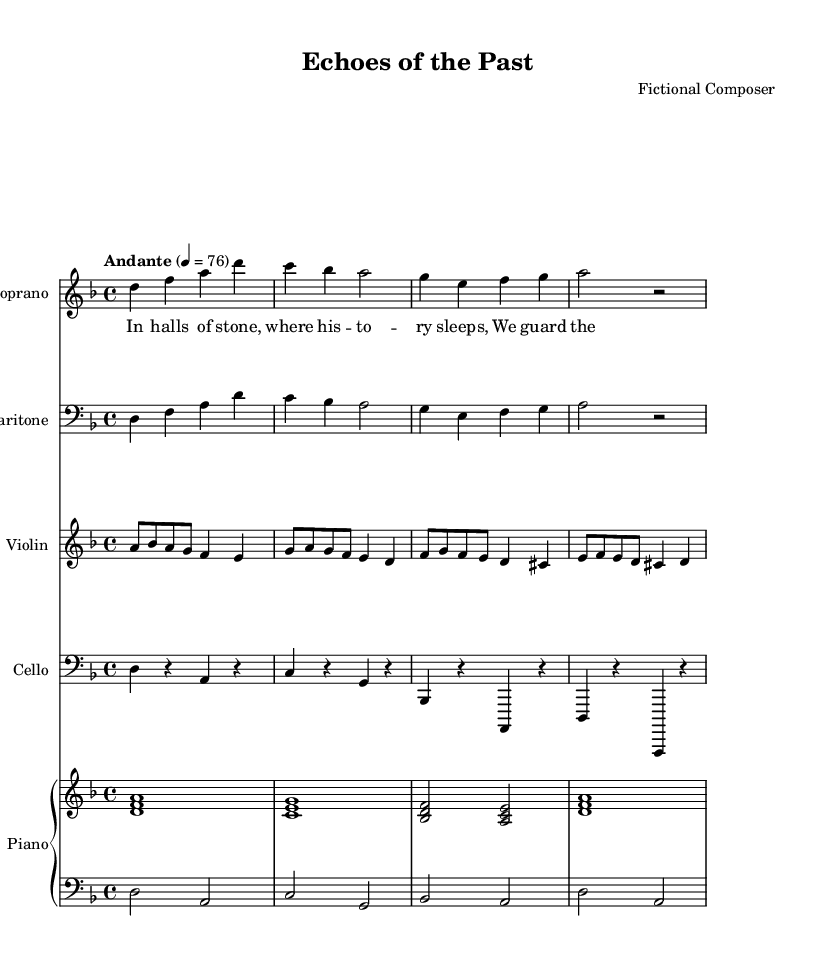What is the key signature of this music? The key signature is D minor, which has one flat (B flat) indicated in the beginning of the staff.
Answer: D minor What is the time signature of this piece? The time signature is 4/4, shown at the beginning of the score, indicating four beats per measure.
Answer: 4/4 What is the tempo marking? The tempo marking is "Andante," which suggests a moderate walking pace. The tempo indication provides a specific speed of 76 beats per minute.
Answer: Andante How many voices are present in this score? The score includes four distinct voices: Soprano, Baritone, Violin, and Cello. This is determined by the number of staves labeled for each instrument.
Answer: Four What instruments are featured in this opera? The instruments featured in this score are Soprano, Baritone, Violin, Cello, and Piano. Each instrument has its own designated staff.
Answer: Soprano, Baritone, Violin, Cello, Piano What is the significance of the lyrics provided? The lyrics emphasize the themes of artifact preservation and the stories hidden within historical artifacts, which align with the opera's exploration of ethical issues in preservation and repatriation.
Answer: Themes of preservation How many bars are in the soprano voice part? The soprano voice part contains four bars, each separating melodic phrases. This can be deduced by counting the measures in the soprano's staff.
Answer: Four bars 